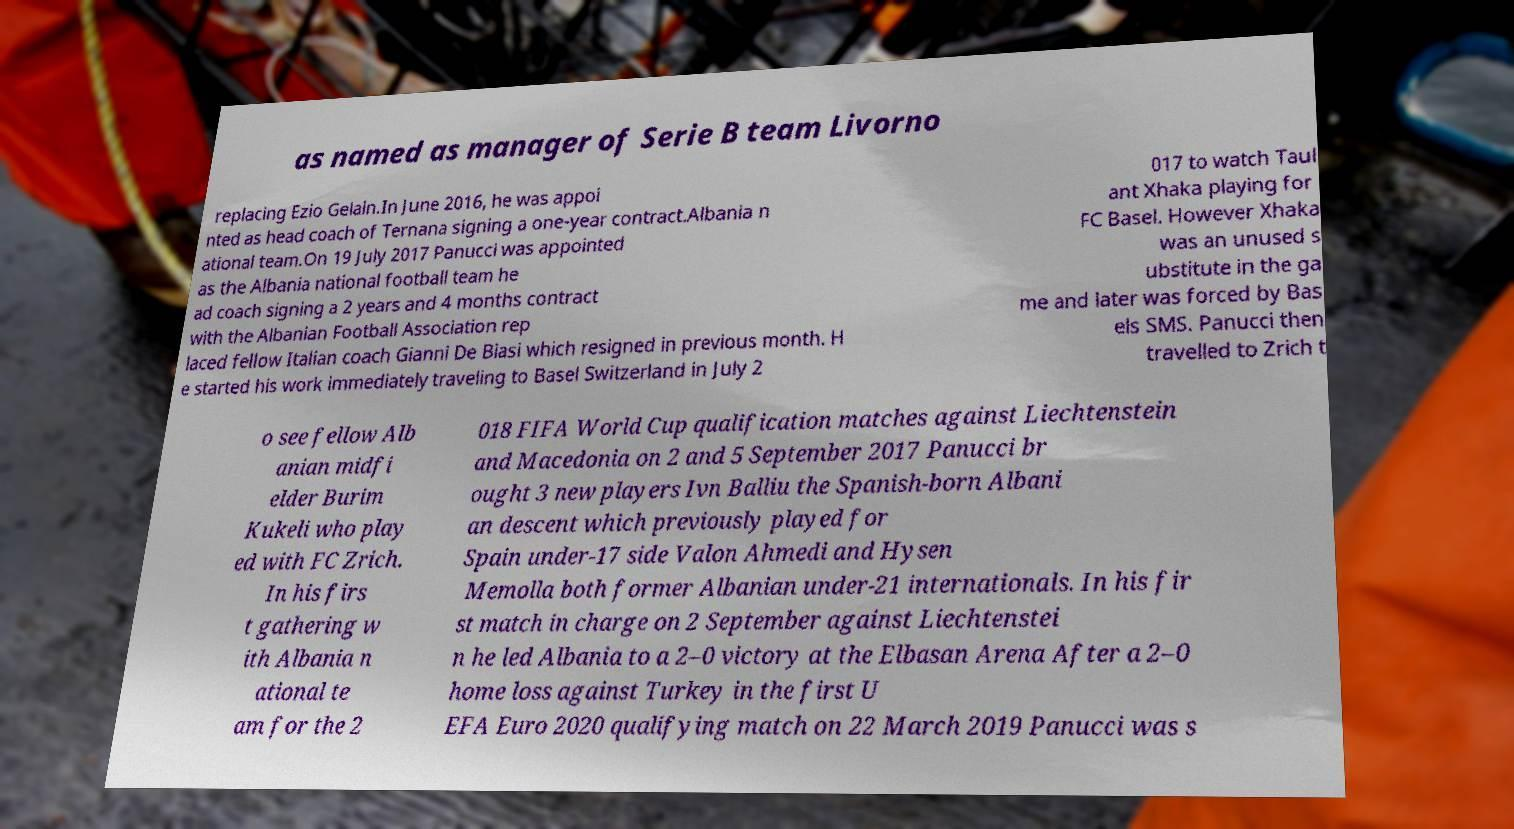Please read and relay the text visible in this image. What does it say? as named as manager of Serie B team Livorno replacing Ezio Gelain.In June 2016, he was appoi nted as head coach of Ternana signing a one-year contract.Albania n ational team.On 19 July 2017 Panucci was appointed as the Albania national football team he ad coach signing a 2 years and 4 months contract with the Albanian Football Association rep laced fellow Italian coach Gianni De Biasi which resigned in previous month. H e started his work immediately traveling to Basel Switzerland in July 2 017 to watch Taul ant Xhaka playing for FC Basel. However Xhaka was an unused s ubstitute in the ga me and later was forced by Bas els SMS. Panucci then travelled to Zrich t o see fellow Alb anian midfi elder Burim Kukeli who play ed with FC Zrich. In his firs t gathering w ith Albania n ational te am for the 2 018 FIFA World Cup qualification matches against Liechtenstein and Macedonia on 2 and 5 September 2017 Panucci br ought 3 new players Ivn Balliu the Spanish-born Albani an descent which previously played for Spain under-17 side Valon Ahmedi and Hysen Memolla both former Albanian under-21 internationals. In his fir st match in charge on 2 September against Liechtenstei n he led Albania to a 2–0 victory at the Elbasan Arena After a 2–0 home loss against Turkey in the first U EFA Euro 2020 qualifying match on 22 March 2019 Panucci was s 